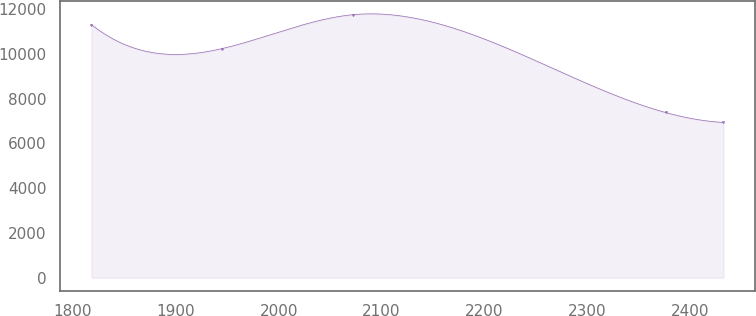Convert chart to OTSL. <chart><loc_0><loc_0><loc_500><loc_500><line_chart><ecel><fcel>Unnamed: 1<nl><fcel>1817.93<fcel>11307.3<nl><fcel>1945.14<fcel>10238.5<nl><fcel>2072.08<fcel>11750.3<nl><fcel>2376.19<fcel>7381.1<nl><fcel>2432.52<fcel>6938.15<nl></chart> 